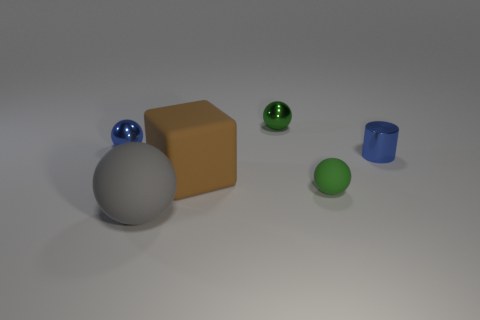Is there anything else that is the same color as the cylinder?
Make the answer very short. Yes. The metal sphere that is the same color as the shiny cylinder is what size?
Ensure brevity in your answer.  Small. Are there any tiny metal things that have the same color as the small cylinder?
Your answer should be very brief. Yes. There is a rubber sphere that is to the right of the green sphere behind the matte object behind the green rubber thing; what is its size?
Keep it short and to the point. Small. There is a gray rubber thing; is it the same size as the brown cube that is behind the green rubber thing?
Give a very brief answer. Yes. What is the color of the matte thing on the left side of the brown rubber block?
Make the answer very short. Gray. What shape is the tiny object that is the same color as the cylinder?
Provide a short and direct response. Sphere. The small shiny object in front of the small blue metal ball has what shape?
Provide a succinct answer. Cylinder. What number of cyan objects are either large matte cubes or metallic spheres?
Offer a terse response. 0. Is the material of the large gray object the same as the big brown block?
Offer a very short reply. Yes. 